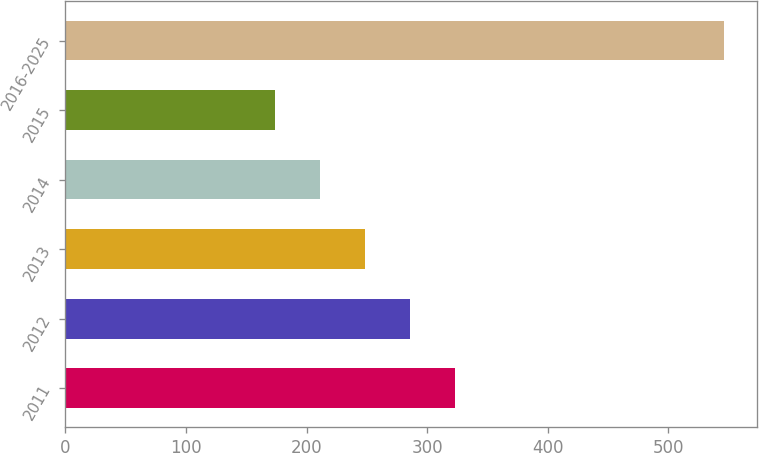<chart> <loc_0><loc_0><loc_500><loc_500><bar_chart><fcel>2011<fcel>2012<fcel>2013<fcel>2014<fcel>2015<fcel>2016-2025<nl><fcel>322.8<fcel>285.6<fcel>248.4<fcel>211.2<fcel>174<fcel>546<nl></chart> 